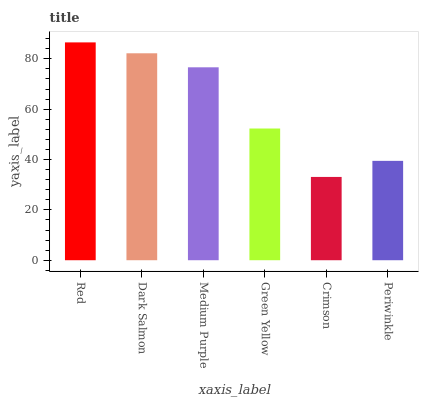Is Crimson the minimum?
Answer yes or no. Yes. Is Red the maximum?
Answer yes or no. Yes. Is Dark Salmon the minimum?
Answer yes or no. No. Is Dark Salmon the maximum?
Answer yes or no. No. Is Red greater than Dark Salmon?
Answer yes or no. Yes. Is Dark Salmon less than Red?
Answer yes or no. Yes. Is Dark Salmon greater than Red?
Answer yes or no. No. Is Red less than Dark Salmon?
Answer yes or no. No. Is Medium Purple the high median?
Answer yes or no. Yes. Is Green Yellow the low median?
Answer yes or no. Yes. Is Green Yellow the high median?
Answer yes or no. No. Is Periwinkle the low median?
Answer yes or no. No. 